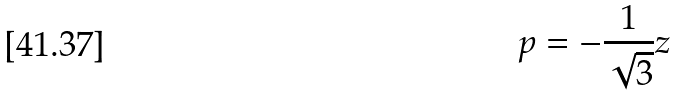<formula> <loc_0><loc_0><loc_500><loc_500>p = - \frac { 1 } { \sqrt { 3 } } z</formula> 